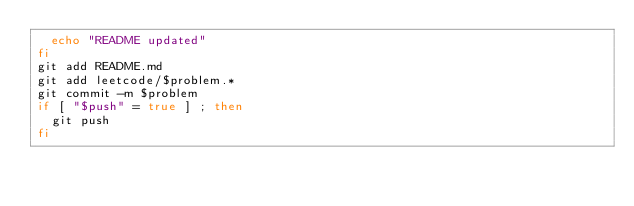Convert code to text. <code><loc_0><loc_0><loc_500><loc_500><_Bash_>  echo "README updated"
fi
git add README.md
git add leetcode/$problem.*
git commit -m $problem
if [ "$push" = true ] ; then
  git push
fi</code> 